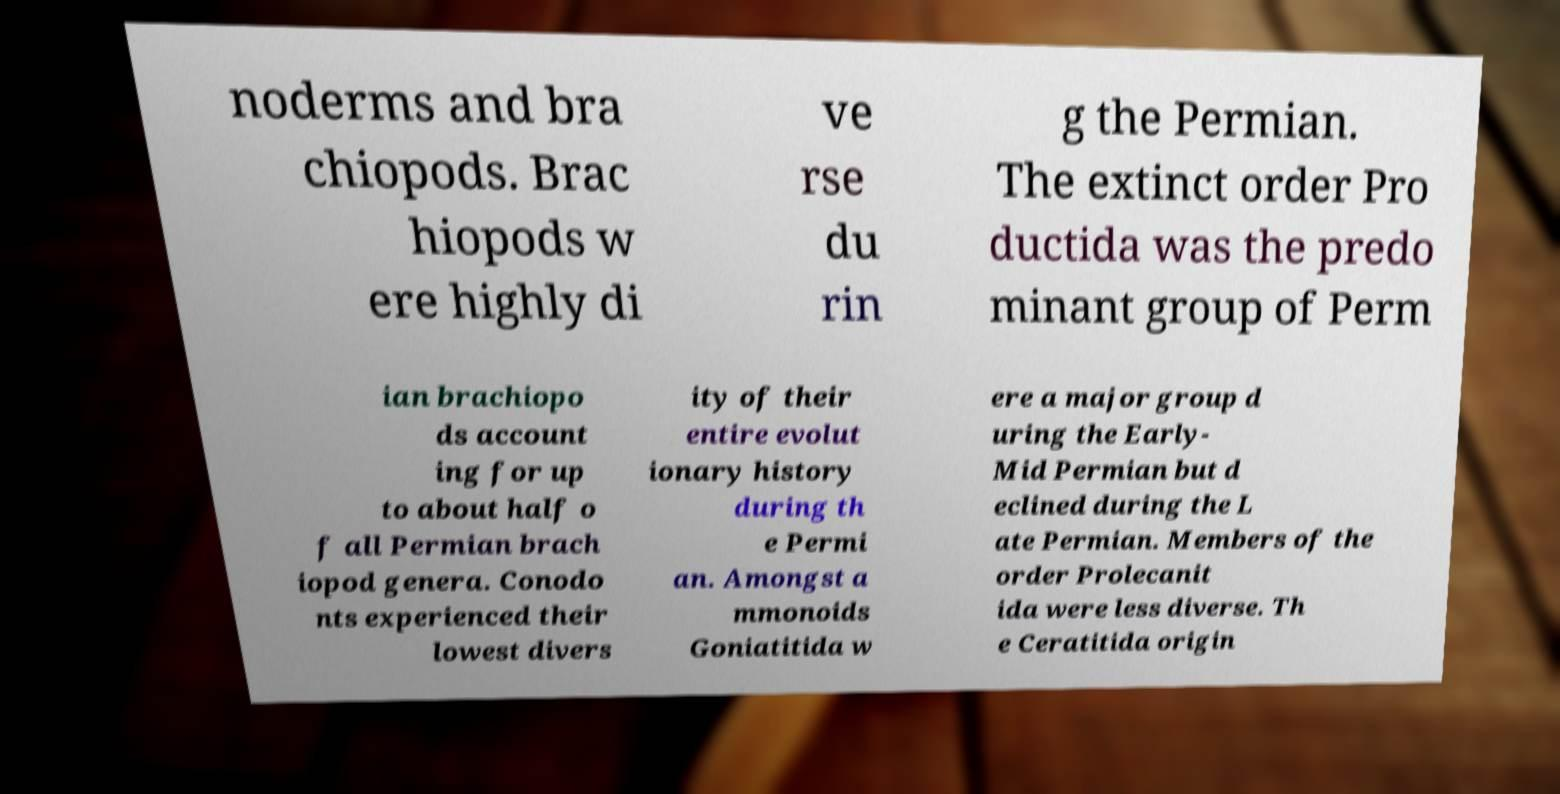Please read and relay the text visible in this image. What does it say? noderms and bra chiopods. Brac hiopods w ere highly di ve rse du rin g the Permian. The extinct order Pro ductida was the predo minant group of Perm ian brachiopo ds account ing for up to about half o f all Permian brach iopod genera. Conodo nts experienced their lowest divers ity of their entire evolut ionary history during th e Permi an. Amongst a mmonoids Goniatitida w ere a major group d uring the Early- Mid Permian but d eclined during the L ate Permian. Members of the order Prolecanit ida were less diverse. Th e Ceratitida origin 